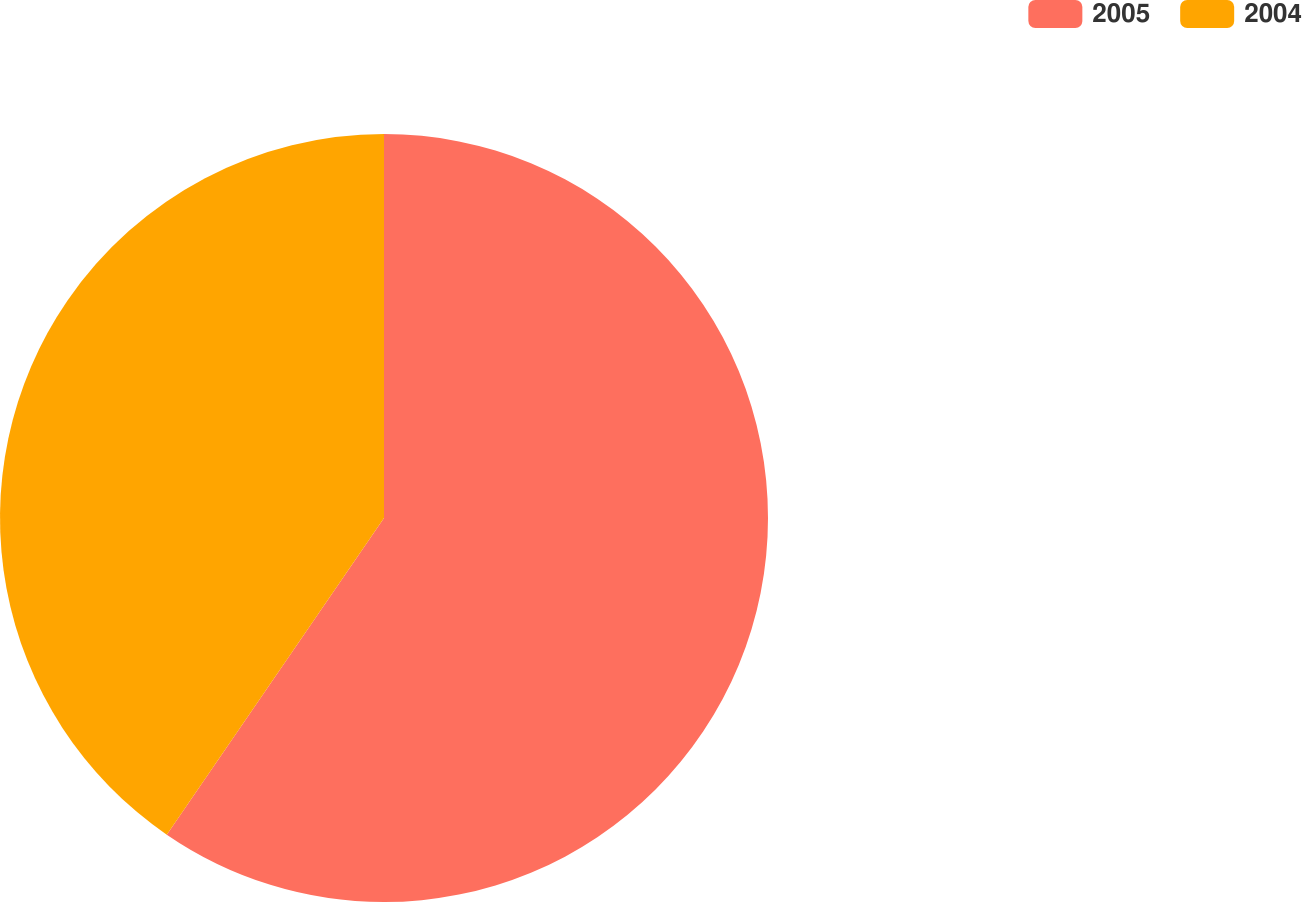Convert chart. <chart><loc_0><loc_0><loc_500><loc_500><pie_chart><fcel>2005<fcel>2004<nl><fcel>59.57%<fcel>40.43%<nl></chart> 